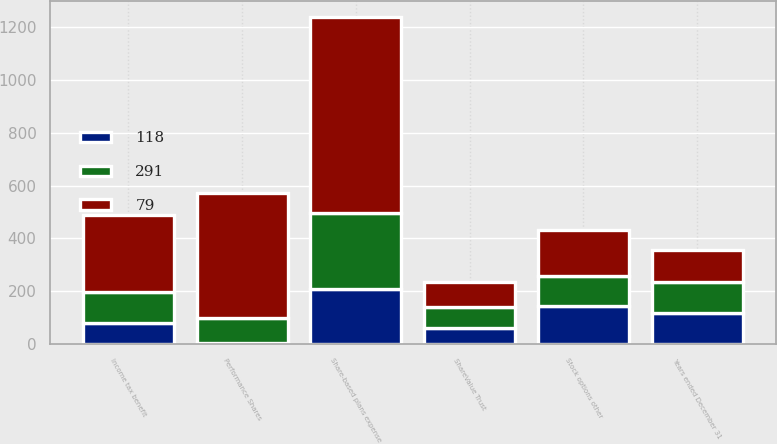Convert chart to OTSL. <chart><loc_0><loc_0><loc_500><loc_500><stacked_bar_chart><ecel><fcel>Years ended December 31<fcel>Performance Shares<fcel>Stock options other<fcel>ShareValue Trust<fcel>Share-based plans expense<fcel>Income tax benefit<nl><fcel>118<fcel>118<fcel>4<fcel>144<fcel>61<fcel>209<fcel>79<nl><fcel>291<fcel>118<fcel>94<fcel>115<fcel>78<fcel>287<fcel>118<nl><fcel>79<fcel>118<fcel>473<fcel>173<fcel>97<fcel>743<fcel>291<nl></chart> 